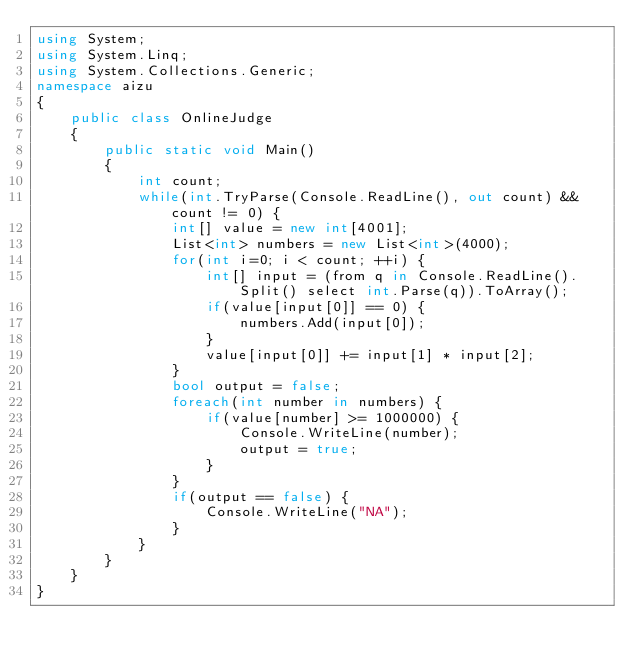Convert code to text. <code><loc_0><loc_0><loc_500><loc_500><_C#_>using System;
using System.Linq;
using System.Collections.Generic;
namespace aizu
{
    public class OnlineJudge
    {
        public static void Main()
        {
            int count;
            while(int.TryParse(Console.ReadLine(), out count) && count != 0) {
                int[] value = new int[4001];
                List<int> numbers = new List<int>(4000);
                for(int i=0; i < count; ++i) {
                    int[] input = (from q in Console.ReadLine().Split() select int.Parse(q)).ToArray();
                    if(value[input[0]] == 0) {
                        numbers.Add(input[0]);
                    }
                    value[input[0]] += input[1] * input[2];
                }
                bool output = false;
                foreach(int number in numbers) {
                    if(value[number] >= 1000000) {
                        Console.WriteLine(number);
                        output = true;
                    }
                }
                if(output == false) {
                    Console.WriteLine("NA");
                }
            }
        }
    }
}</code> 